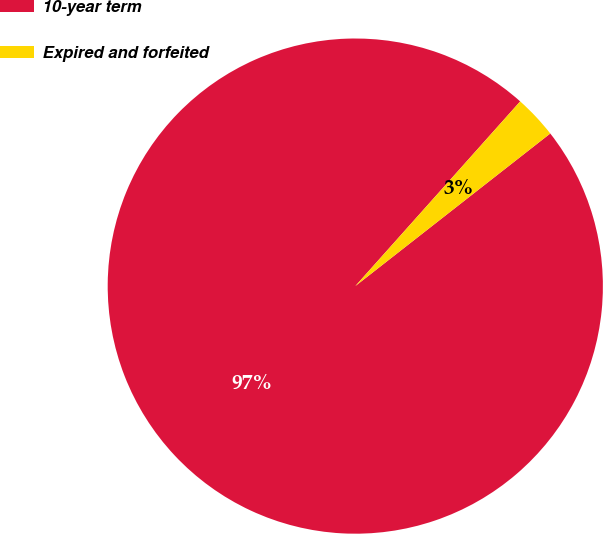<chart> <loc_0><loc_0><loc_500><loc_500><pie_chart><fcel>10-year term<fcel>Expired and forfeited<nl><fcel>97.17%<fcel>2.83%<nl></chart> 